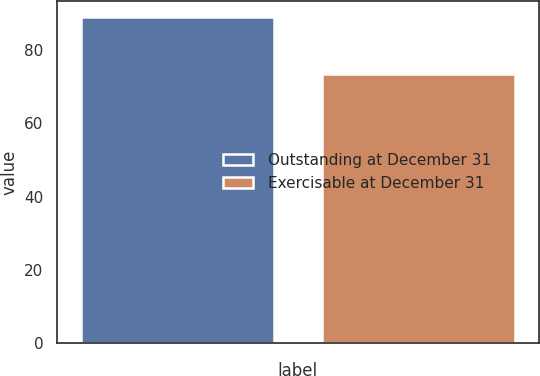Convert chart to OTSL. <chart><loc_0><loc_0><loc_500><loc_500><bar_chart><fcel>Outstanding at December 31<fcel>Exercisable at December 31<nl><fcel>88.95<fcel>73.39<nl></chart> 